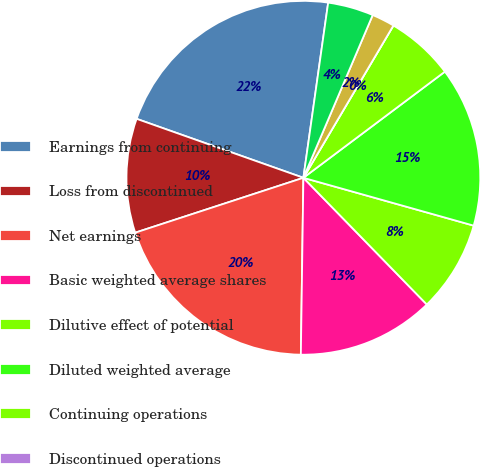<chart> <loc_0><loc_0><loc_500><loc_500><pie_chart><fcel>Earnings from continuing<fcel>Loss from discontinued<fcel>Net earnings<fcel>Basic weighted average shares<fcel>Dilutive effect of potential<fcel>Diluted weighted average<fcel>Continuing operations<fcel>Discontinued operations<fcel>Net earnings per share<fcel>Net earnings (loss) per<nl><fcel>21.83%<fcel>10.43%<fcel>19.75%<fcel>12.52%<fcel>8.35%<fcel>14.6%<fcel>6.26%<fcel>0.0%<fcel>2.09%<fcel>4.17%<nl></chart> 